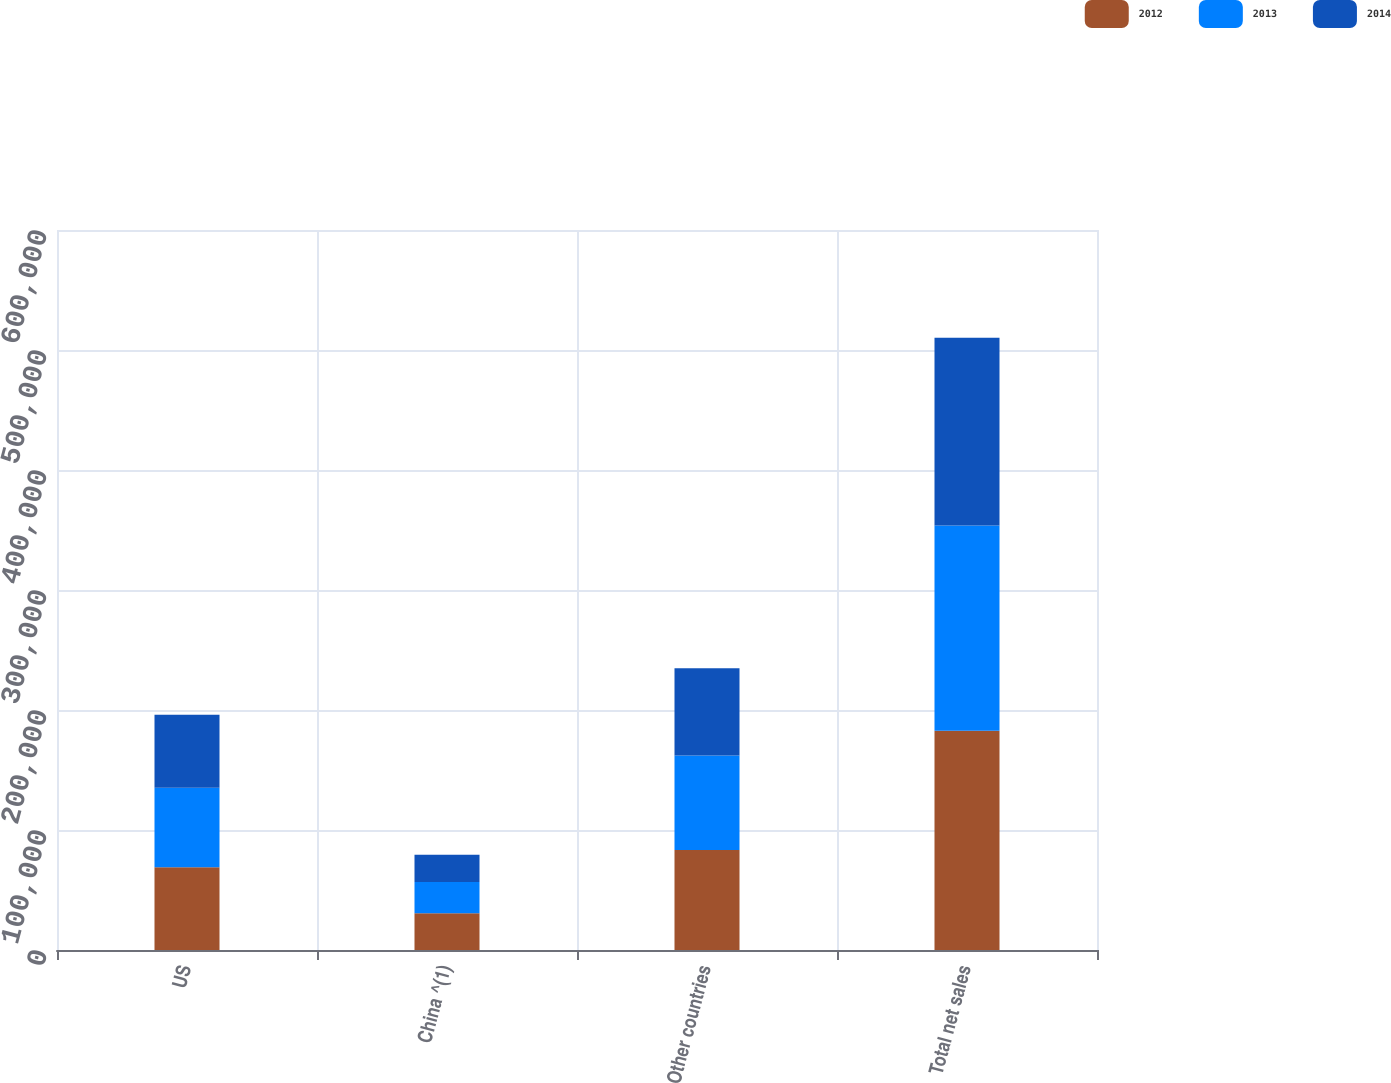Convert chart. <chart><loc_0><loc_0><loc_500><loc_500><stacked_bar_chart><ecel><fcel>US<fcel>China ^(1)<fcel>Other countries<fcel>Total net sales<nl><fcel>2012<fcel>68909<fcel>30638<fcel>83248<fcel>182795<nl><fcel>2013<fcel>66197<fcel>25946<fcel>78767<fcel>170910<nl><fcel>2014<fcel>60949<fcel>22797<fcel>72762<fcel>156508<nl></chart> 